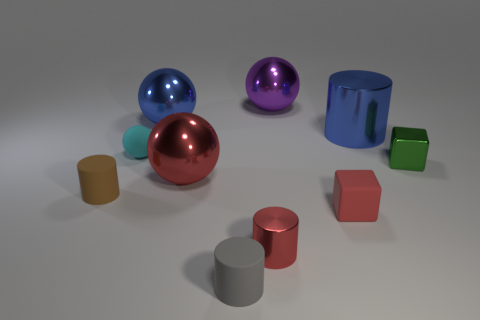What number of yellow things are small matte cylinders or tiny shiny cylinders?
Provide a short and direct response. 0. The cyan ball is what size?
Provide a short and direct response. Small. How many rubber things are red cylinders or small spheres?
Ensure brevity in your answer.  1. Are there fewer cyan spheres than big metallic spheres?
Give a very brief answer. Yes. What number of other things are made of the same material as the tiny green thing?
Give a very brief answer. 5. What size is the blue metal thing that is the same shape as the tiny gray thing?
Give a very brief answer. Large. Is the cylinder to the left of the small cyan thing made of the same material as the cyan thing on the left side of the red block?
Your answer should be compact. Yes. Are there fewer large blue metallic cylinders that are to the right of the blue metal cylinder than tiny brown rubber objects?
Provide a succinct answer. Yes. The other matte object that is the same shape as the big red object is what color?
Offer a terse response. Cyan. Does the matte object that is on the right side of the purple shiny sphere have the same size as the small gray cylinder?
Offer a terse response. Yes. 